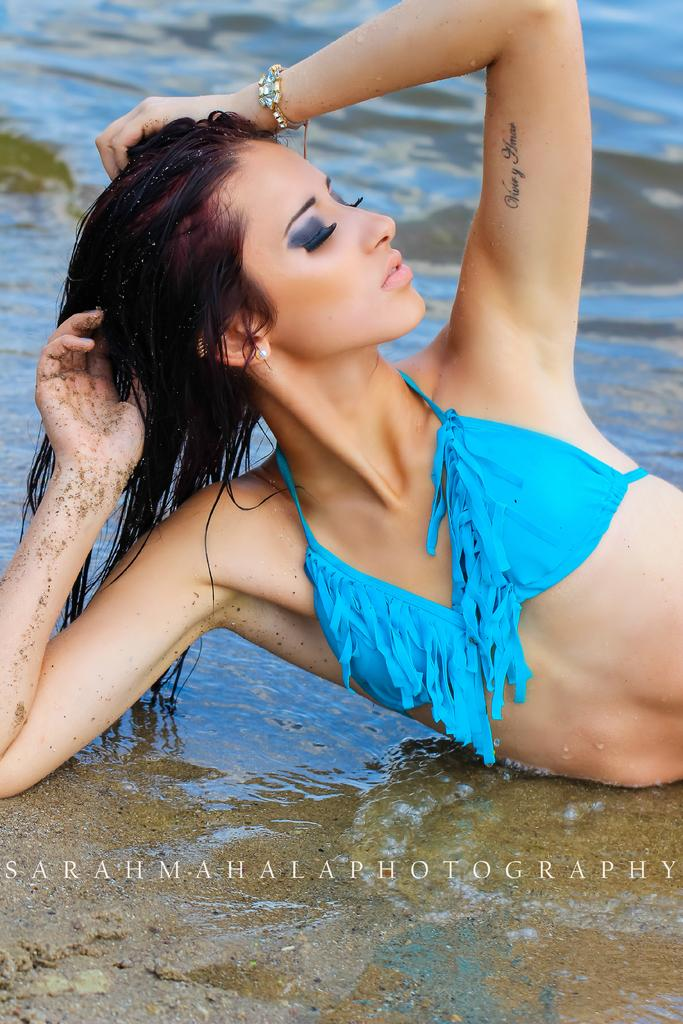Who is the main subject in the image? There is a woman in the image. What is the woman doing in the image? The woman is lying on the water. What can be seen in the background of the image? There is water visible in the background of the image. Reasoning: Let'g: Let's think step by step in order to produce the conversation. We start by identifying the main subject in the image, which is the woman. Then, we describe what the woman is doing, which is lying on the water. Finally, we mention the background of the image, which is water. Each question is designed to elicit a specific detail about the image that is known from the provided facts. Absurd Question/Answer: How many sheep are visible in the image? There are no sheep present in the image. What type of loss is the woman experiencing in the image? There is no indication of any loss in the image; the woman is simply lying on the water. What type of wax is being used to create the woman's likeness in the image? There is no indication that the woman's likeness is being created with wax in the image. 